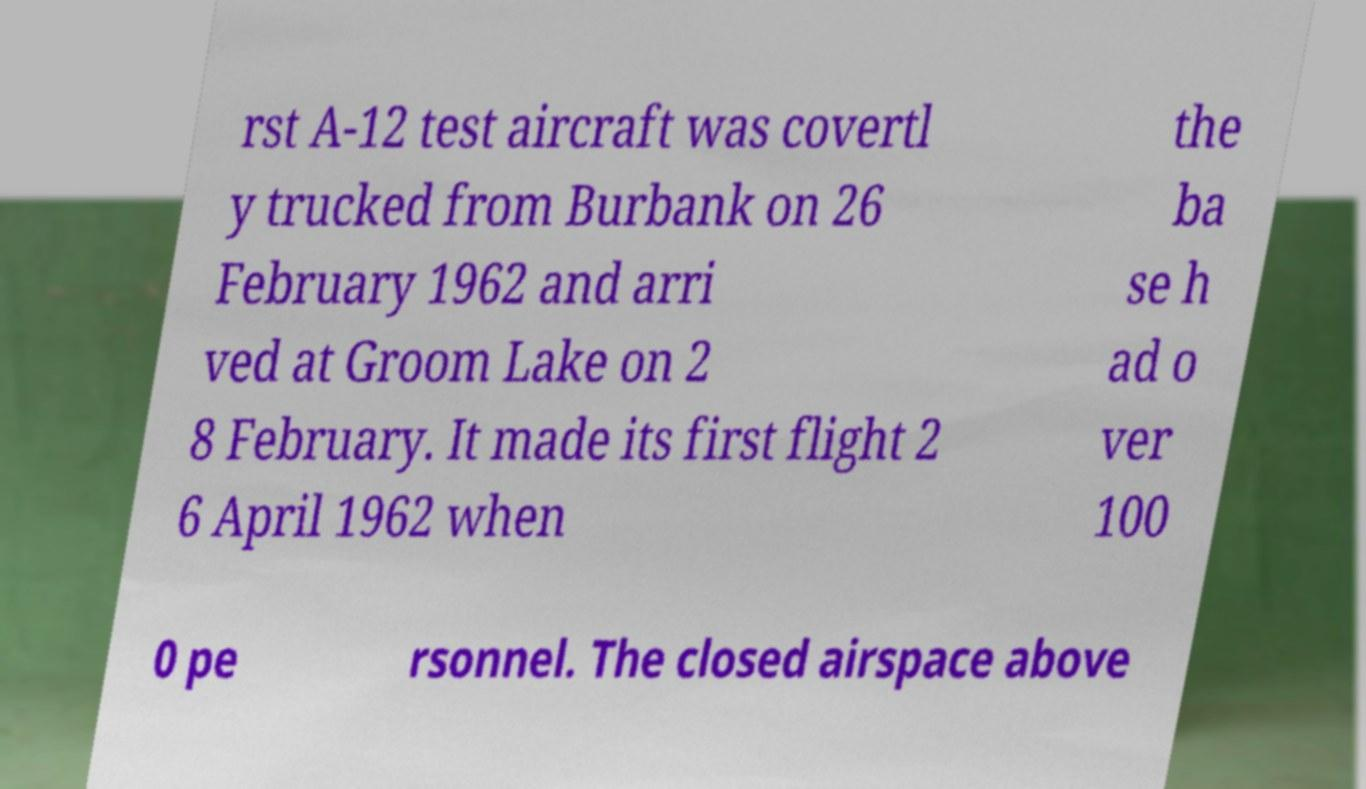There's text embedded in this image that I need extracted. Can you transcribe it verbatim? rst A-12 test aircraft was covertl y trucked from Burbank on 26 February 1962 and arri ved at Groom Lake on 2 8 February. It made its first flight 2 6 April 1962 when the ba se h ad o ver 100 0 pe rsonnel. The closed airspace above 